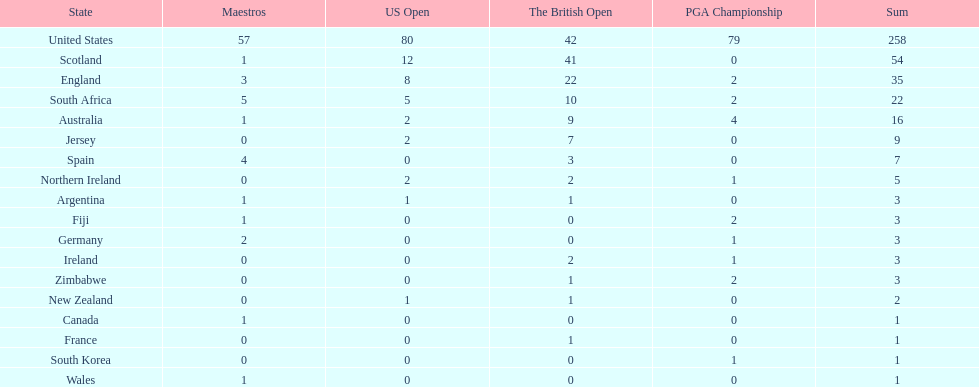Parse the table in full. {'header': ['State', 'Maestros', 'US Open', 'The British Open', 'PGA Championship', 'Sum'], 'rows': [['United States', '57', '80', '42', '79', '258'], ['Scotland', '1', '12', '41', '0', '54'], ['England', '3', '8', '22', '2', '35'], ['South Africa', '5', '5', '10', '2', '22'], ['Australia', '1', '2', '9', '4', '16'], ['Jersey', '0', '2', '7', '0', '9'], ['Spain', '4', '0', '3', '0', '7'], ['Northern Ireland', '0', '2', '2', '1', '5'], ['Argentina', '1', '1', '1', '0', '3'], ['Fiji', '1', '0', '0', '2', '3'], ['Germany', '2', '0', '0', '1', '3'], ['Ireland', '0', '0', '2', '1', '3'], ['Zimbabwe', '0', '0', '1', '2', '3'], ['New Zealand', '0', '1', '1', '0', '2'], ['Canada', '1', '0', '0', '0', '1'], ['France', '0', '0', '1', '0', '1'], ['South Korea', '0', '0', '0', '1', '1'], ['Wales', '1', '0', '0', '0', '1']]} Which country has the most pga championships. United States. 